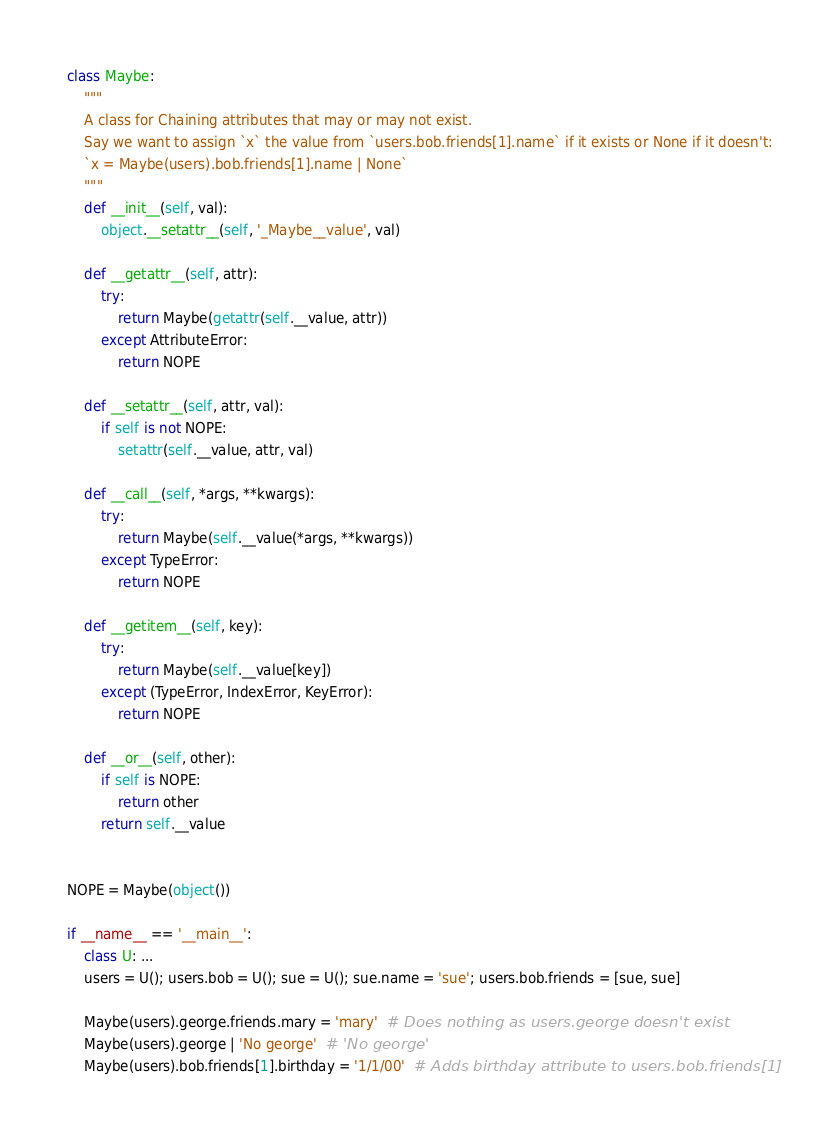<code> <loc_0><loc_0><loc_500><loc_500><_Python_>class Maybe:
    """
    A class for Chaining attributes that may or may not exist.
    Say we want to assign `x` the value from `users.bob.friends[1].name` if it exists or None if it doesn't:
    `x = Maybe(users).bob.friends[1].name | None`
    """
    def __init__(self, val):
        object.__setattr__(self, '_Maybe__value', val)

    def __getattr__(self, attr):
        try:
            return Maybe(getattr(self.__value, attr))
        except AttributeError:
            return NOPE

    def __setattr__(self, attr, val):
        if self is not NOPE:
            setattr(self.__value, attr, val)

    def __call__(self, *args, **kwargs):
        try:
            return Maybe(self.__value(*args, **kwargs))
        except TypeError:
            return NOPE

    def __getitem__(self, key):
        try:
            return Maybe(self.__value[key])
        except (TypeError, IndexError, KeyError):
            return NOPE

    def __or__(self, other):
        if self is NOPE:
            return other
        return self.__value


NOPE = Maybe(object())

if __name__ == '__main__':
    class U: ...
    users = U(); users.bob = U(); sue = U(); sue.name = 'sue'; users.bob.friends = [sue, sue]

    Maybe(users).george.friends.mary = 'mary'  # Does nothing as users.george doesn't exist
    Maybe(users).george | 'No george'  # 'No george'
    Maybe(users).bob.friends[1].birthday = '1/1/00'  # Adds birthday attribute to users.bob.friends[1]</code> 